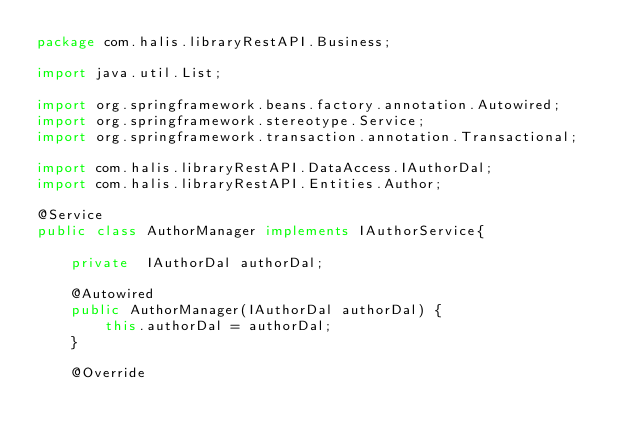Convert code to text. <code><loc_0><loc_0><loc_500><loc_500><_Java_>package com.halis.libraryRestAPI.Business;

import java.util.List;

import org.springframework.beans.factory.annotation.Autowired;
import org.springframework.stereotype.Service;
import org.springframework.transaction.annotation.Transactional;

import com.halis.libraryRestAPI.DataAccess.IAuthorDal;
import com.halis.libraryRestAPI.Entities.Author;

@Service
public class AuthorManager implements IAuthorService{
	
	private  IAuthorDal authorDal;
	
	@Autowired
	public AuthorManager(IAuthorDal authorDal) {
		this.authorDal = authorDal;
	}

	@Override</code> 